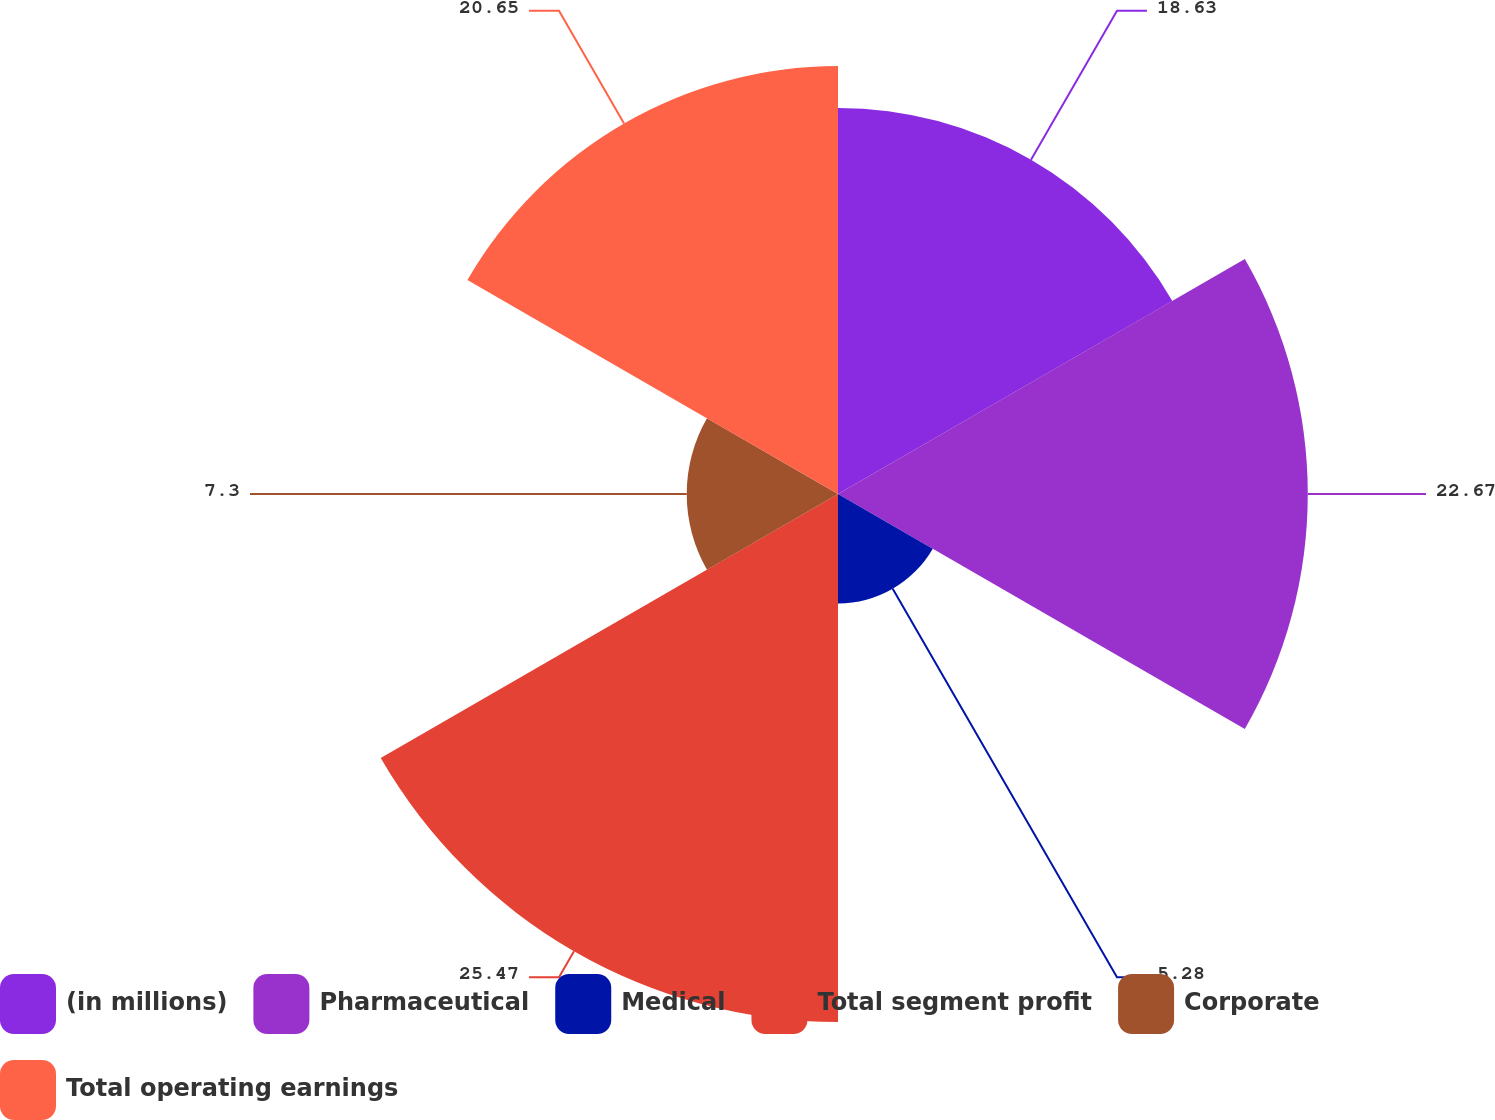<chart> <loc_0><loc_0><loc_500><loc_500><pie_chart><fcel>(in millions)<fcel>Pharmaceutical<fcel>Medical<fcel>Total segment profit<fcel>Corporate<fcel>Total operating earnings<nl><fcel>18.63%<fcel>22.67%<fcel>5.28%<fcel>25.48%<fcel>7.3%<fcel>20.65%<nl></chart> 